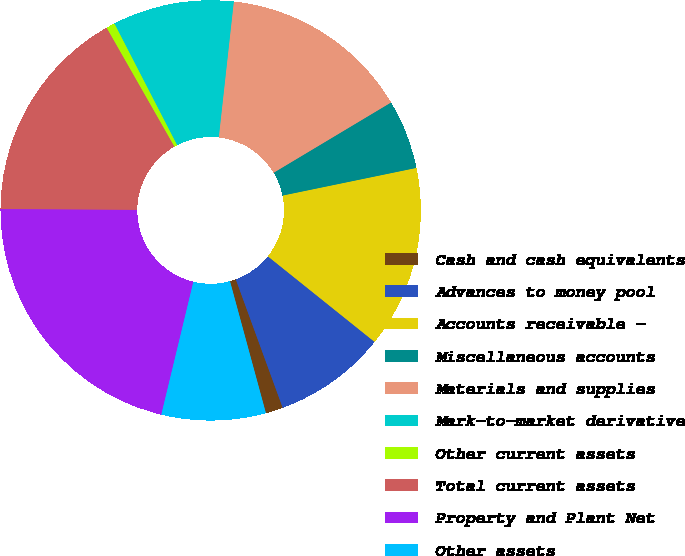<chart> <loc_0><loc_0><loc_500><loc_500><pie_chart><fcel>Cash and cash equivalents<fcel>Advances to money pool<fcel>Accounts receivable -<fcel>Miscellaneous accounts<fcel>Materials and supplies<fcel>Mark-to-market derivative<fcel>Other current assets<fcel>Total current assets<fcel>Property and Plant Net<fcel>Other assets<nl><fcel>1.34%<fcel>8.67%<fcel>14.0%<fcel>5.34%<fcel>14.66%<fcel>9.33%<fcel>0.67%<fcel>16.66%<fcel>21.32%<fcel>8.0%<nl></chart> 